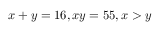Convert formula to latex. <formula><loc_0><loc_0><loc_500><loc_500>x + y = 1 6 , x y = 5 5 , x > y</formula> 